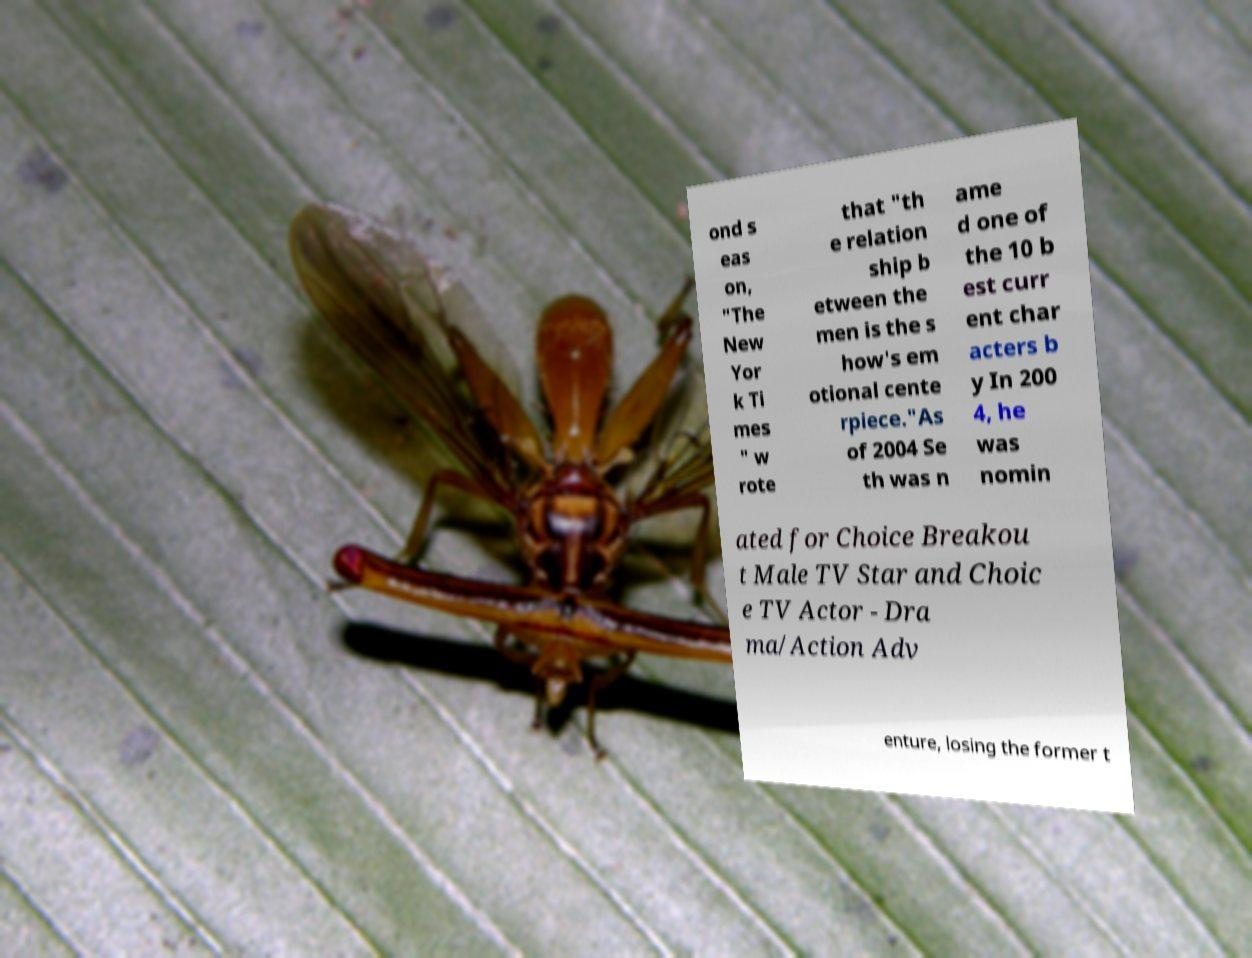Could you assist in decoding the text presented in this image and type it out clearly? ond s eas on, "The New Yor k Ti mes " w rote that "th e relation ship b etween the men is the s how's em otional cente rpiece."As of 2004 Se th was n ame d one of the 10 b est curr ent char acters b y In 200 4, he was nomin ated for Choice Breakou t Male TV Star and Choic e TV Actor - Dra ma/Action Adv enture, losing the former t 